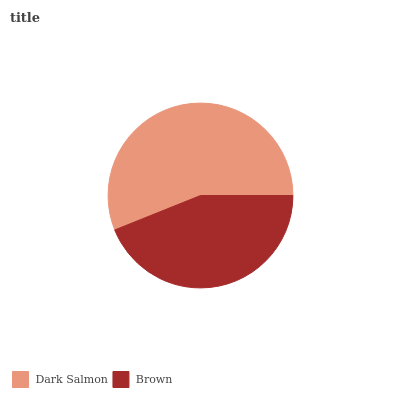Is Brown the minimum?
Answer yes or no. Yes. Is Dark Salmon the maximum?
Answer yes or no. Yes. Is Brown the maximum?
Answer yes or no. No. Is Dark Salmon greater than Brown?
Answer yes or no. Yes. Is Brown less than Dark Salmon?
Answer yes or no. Yes. Is Brown greater than Dark Salmon?
Answer yes or no. No. Is Dark Salmon less than Brown?
Answer yes or no. No. Is Dark Salmon the high median?
Answer yes or no. Yes. Is Brown the low median?
Answer yes or no. Yes. Is Brown the high median?
Answer yes or no. No. Is Dark Salmon the low median?
Answer yes or no. No. 